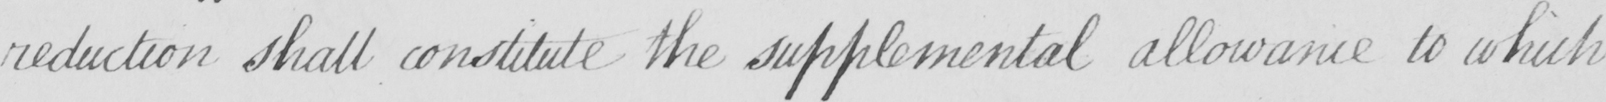Can you tell me what this handwritten text says? reduction shall constitute the supplemental allowance to which 